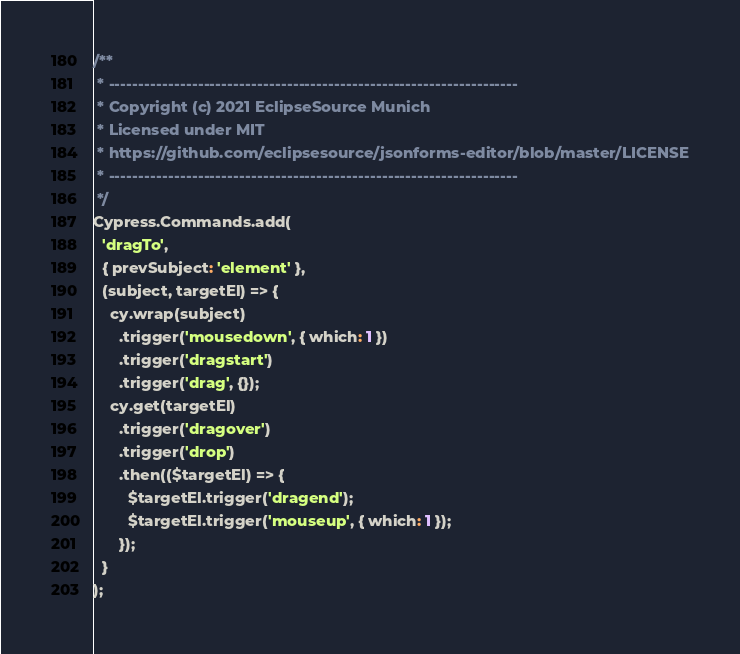Convert code to text. <code><loc_0><loc_0><loc_500><loc_500><_JavaScript_>/**
 * ---------------------------------------------------------------------
 * Copyright (c) 2021 EclipseSource Munich
 * Licensed under MIT
 * https://github.com/eclipsesource/jsonforms-editor/blob/master/LICENSE
 * ---------------------------------------------------------------------
 */
Cypress.Commands.add(
  'dragTo',
  { prevSubject: 'element' },
  (subject, targetEl) => {
    cy.wrap(subject)
      .trigger('mousedown', { which: 1 })
      .trigger('dragstart')
      .trigger('drag', {});
    cy.get(targetEl)
      .trigger('dragover')
      .trigger('drop')
      .then(($targetEl) => {
        $targetEl.trigger('dragend');
        $targetEl.trigger('mouseup', { which: 1 });
      });
  }
);
</code> 